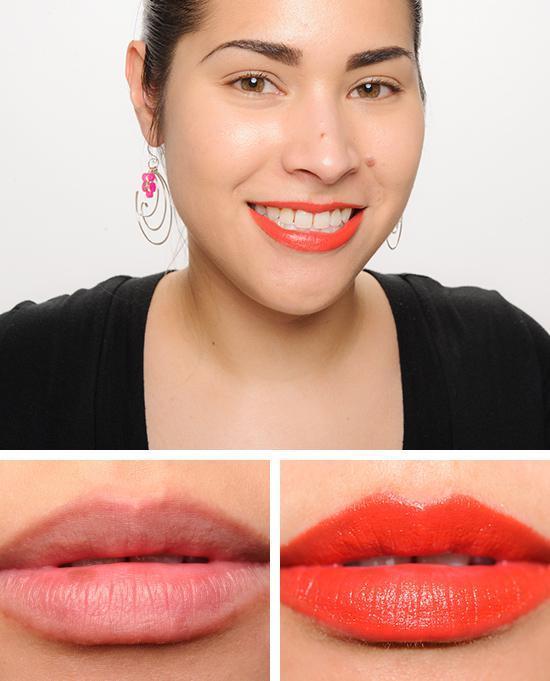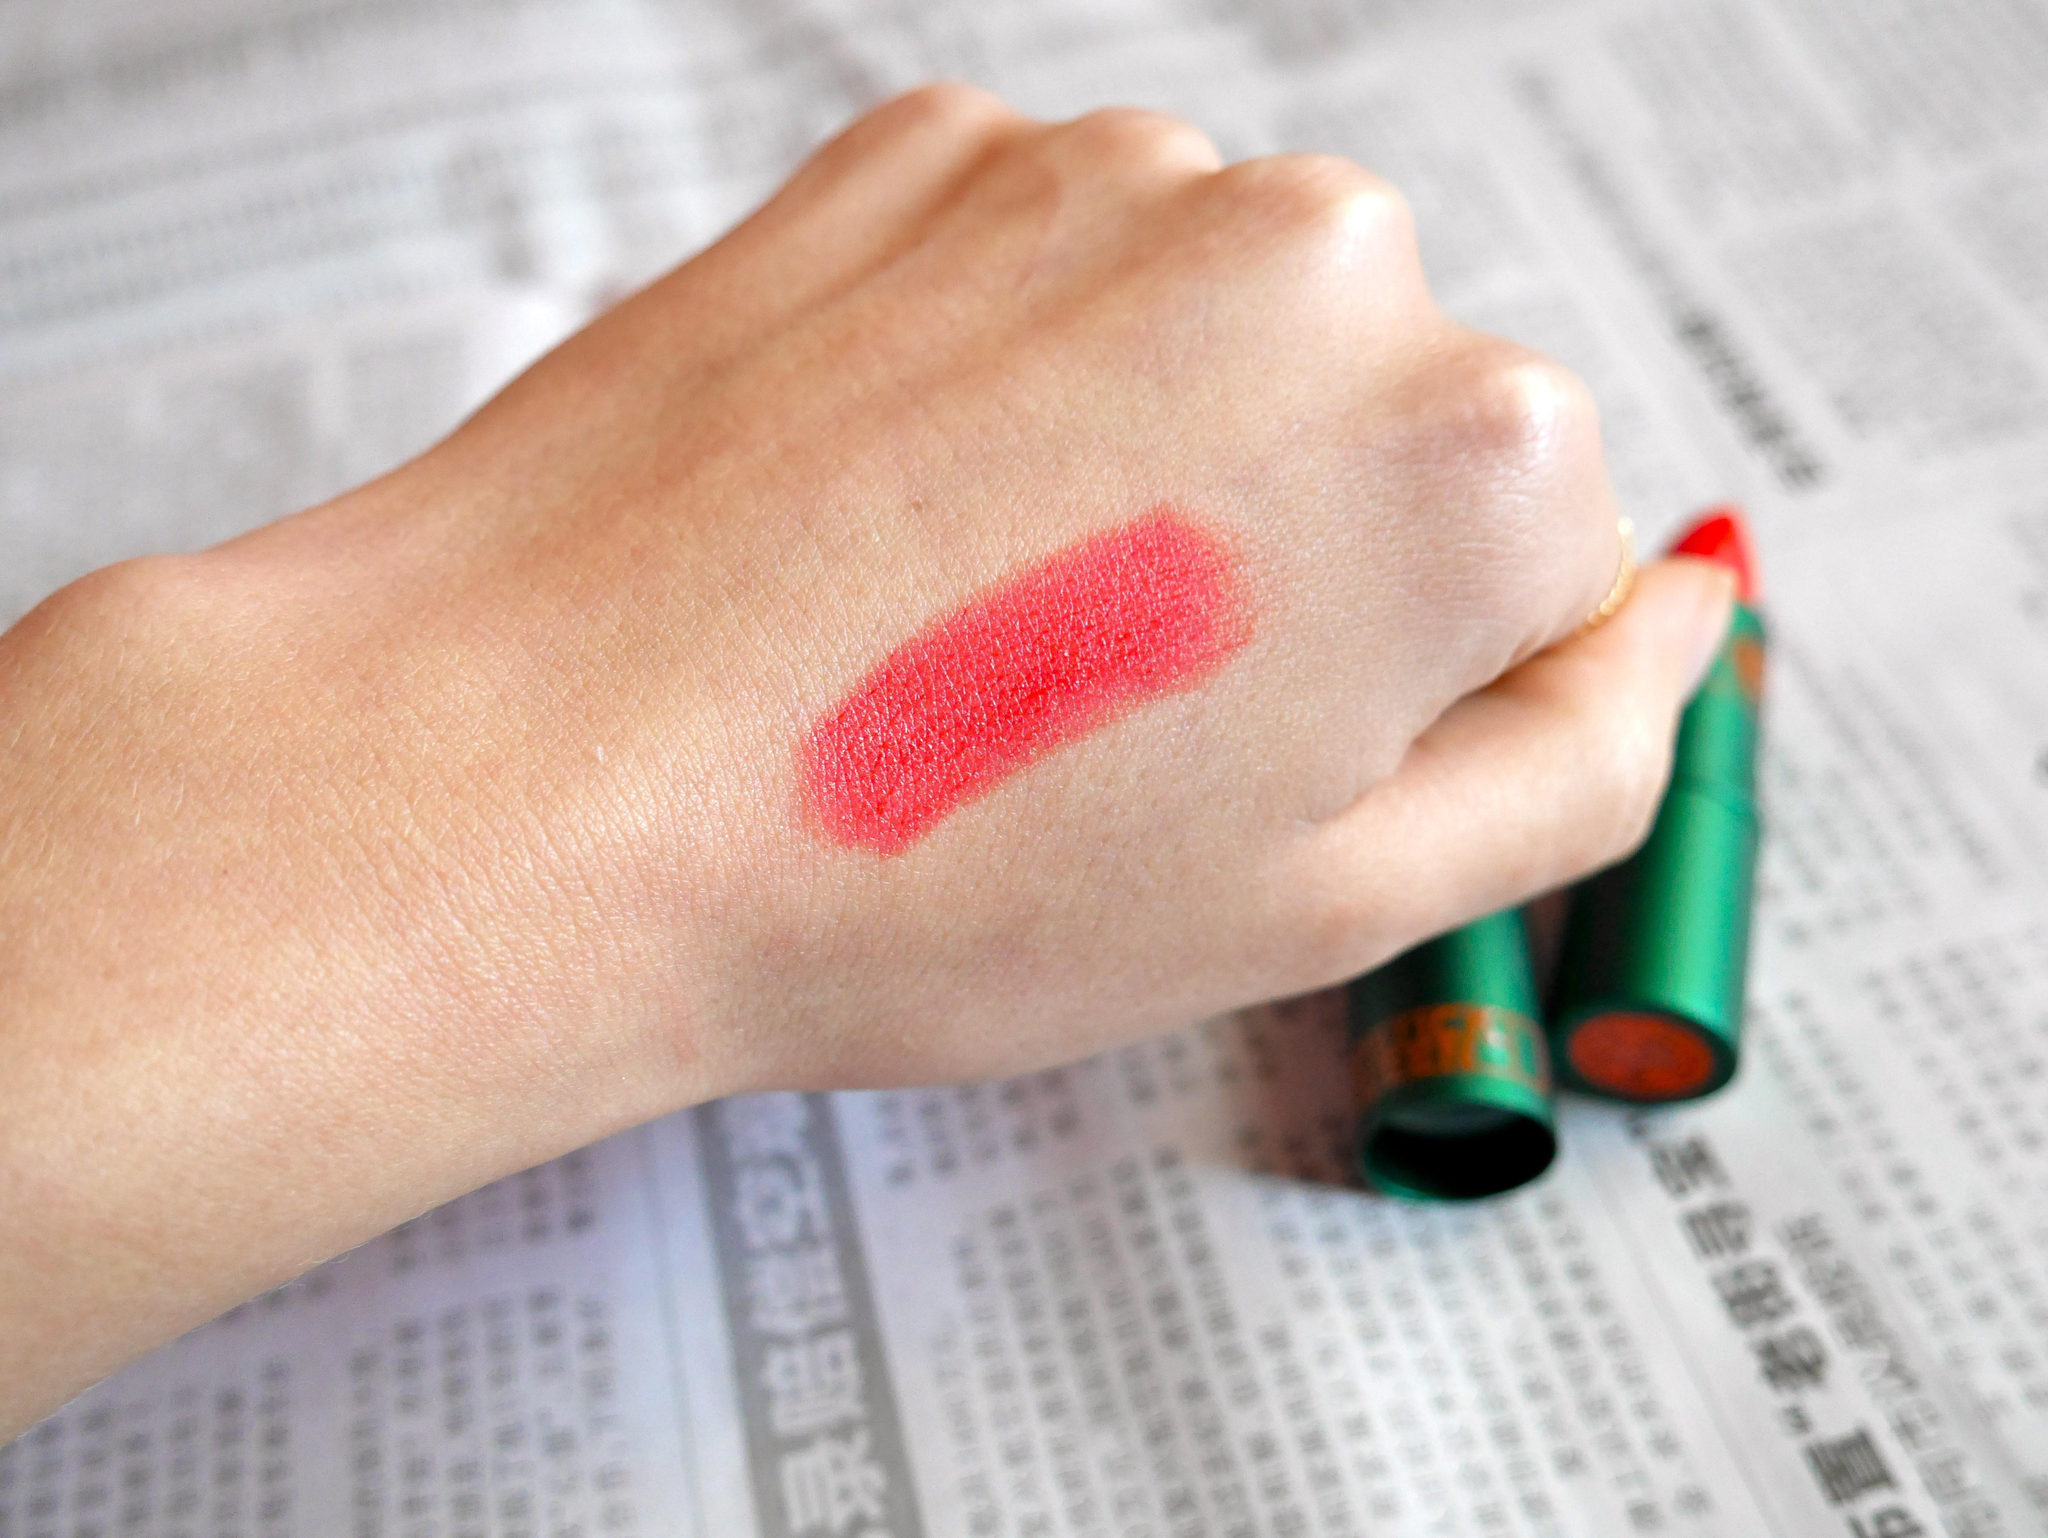The first image is the image on the left, the second image is the image on the right. Examine the images to the left and right. Is the description "One image includes tinted lips, and the other shows a color sample on skin." accurate? Answer yes or no. Yes. The first image is the image on the left, the second image is the image on the right. For the images shown, is this caption "There is one lipstick mark across the person's skin on the image on the right." true? Answer yes or no. Yes. 